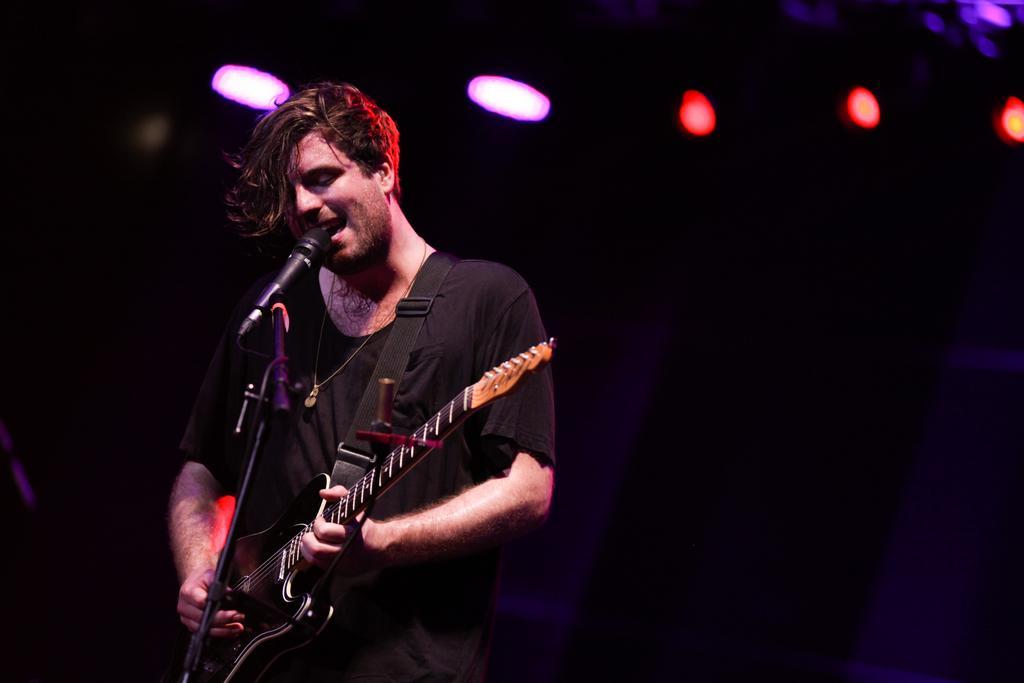Please provide a concise description of this image. In this image we can see a person standing and playing a guitar, there is a microphone in front of him and there are lights in the background. 